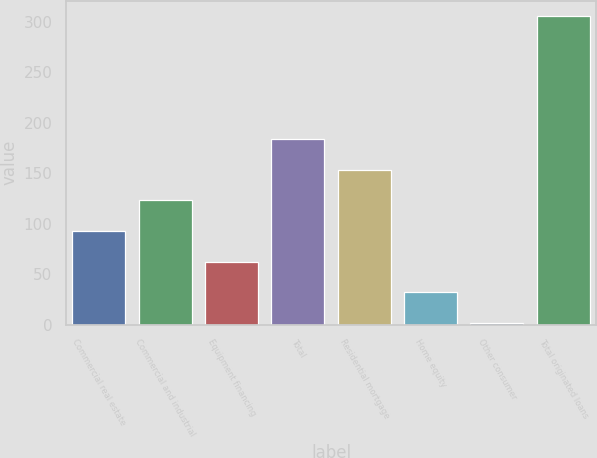Convert chart. <chart><loc_0><loc_0><loc_500><loc_500><bar_chart><fcel>Commercial real estate<fcel>Commercial and industrial<fcel>Equipment financing<fcel>Total<fcel>Residential mortgage<fcel>Home equity<fcel>Other consumer<fcel>Total originated loans<nl><fcel>92.88<fcel>123.24<fcel>62.52<fcel>183.96<fcel>153.6<fcel>32.16<fcel>1.8<fcel>305.4<nl></chart> 